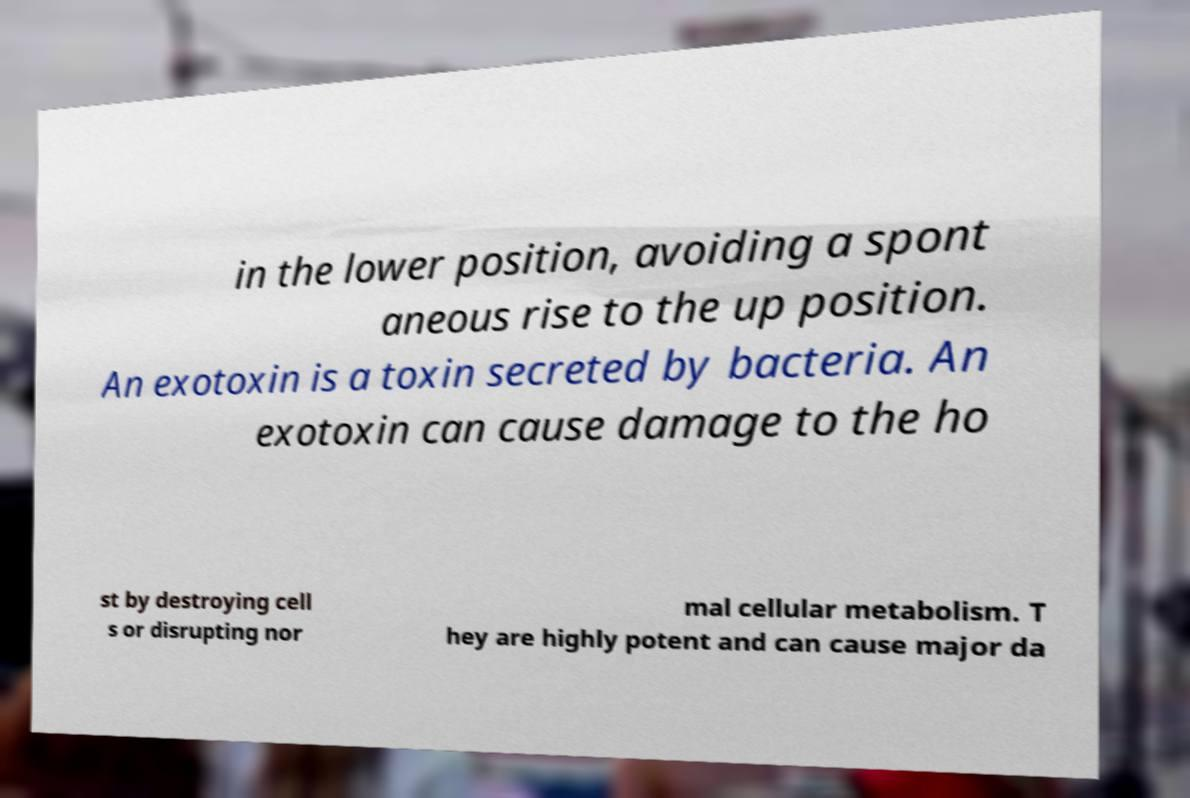Could you assist in decoding the text presented in this image and type it out clearly? in the lower position, avoiding a spont aneous rise to the up position. An exotoxin is a toxin secreted by bacteria. An exotoxin can cause damage to the ho st by destroying cell s or disrupting nor mal cellular metabolism. T hey are highly potent and can cause major da 